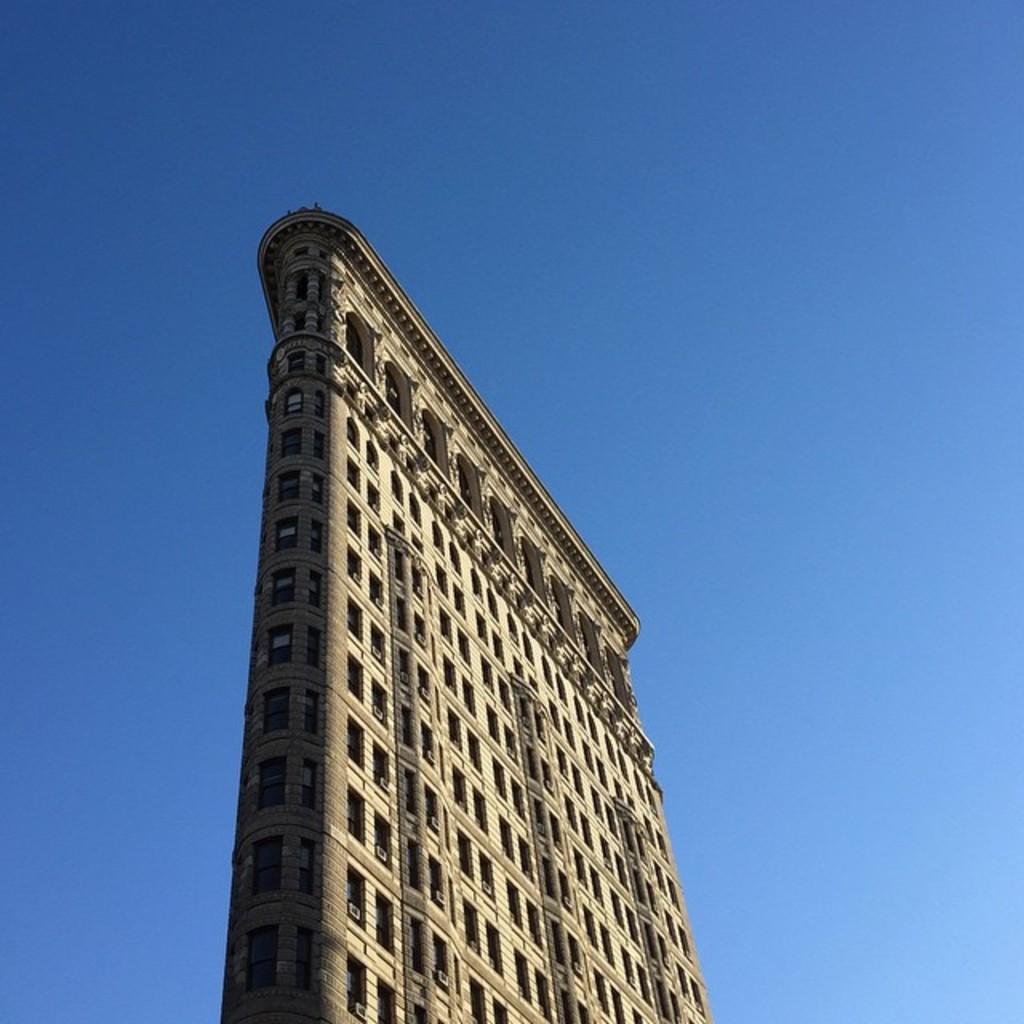Describe this image in one or two sentences. In this image we can see a building and sky in the background. 